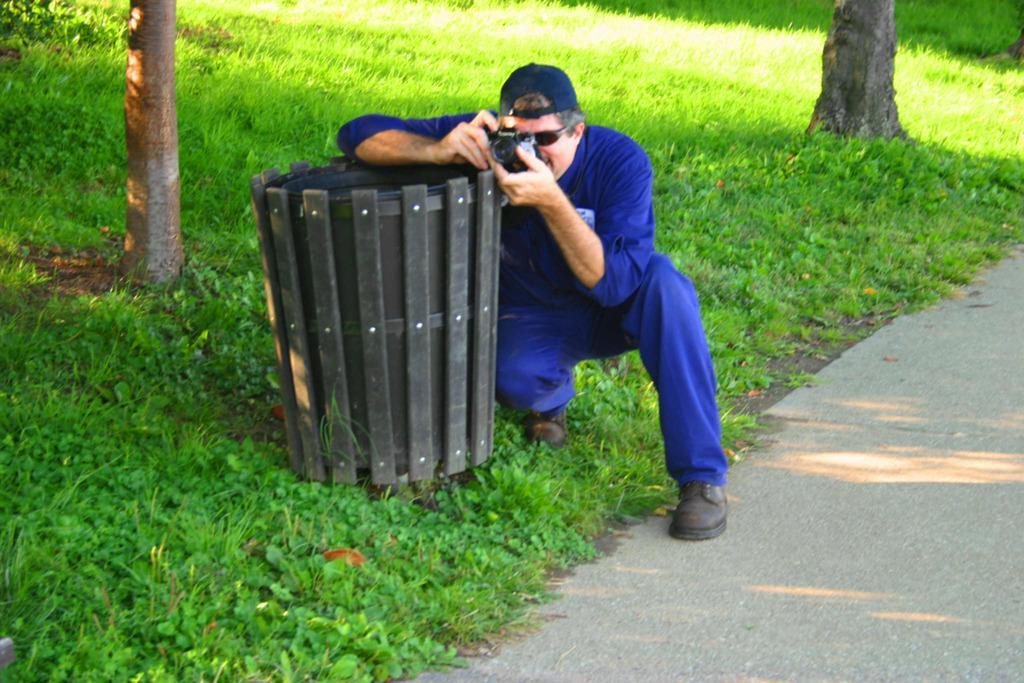How would you summarize this image in a sentence or two? In the center of the picture there are plants, dustbin and a person holding a camera. At the top right there are plants and a tree. On the left there are plants, grass and a tree. On the right it is road. 